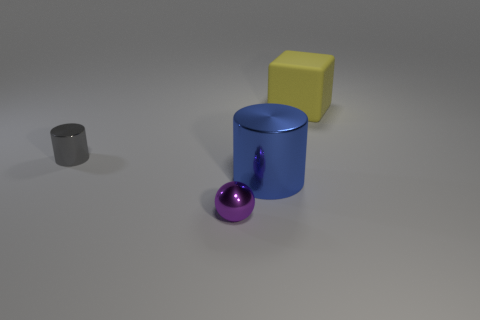What number of other things are there of the same material as the gray cylinder 2 